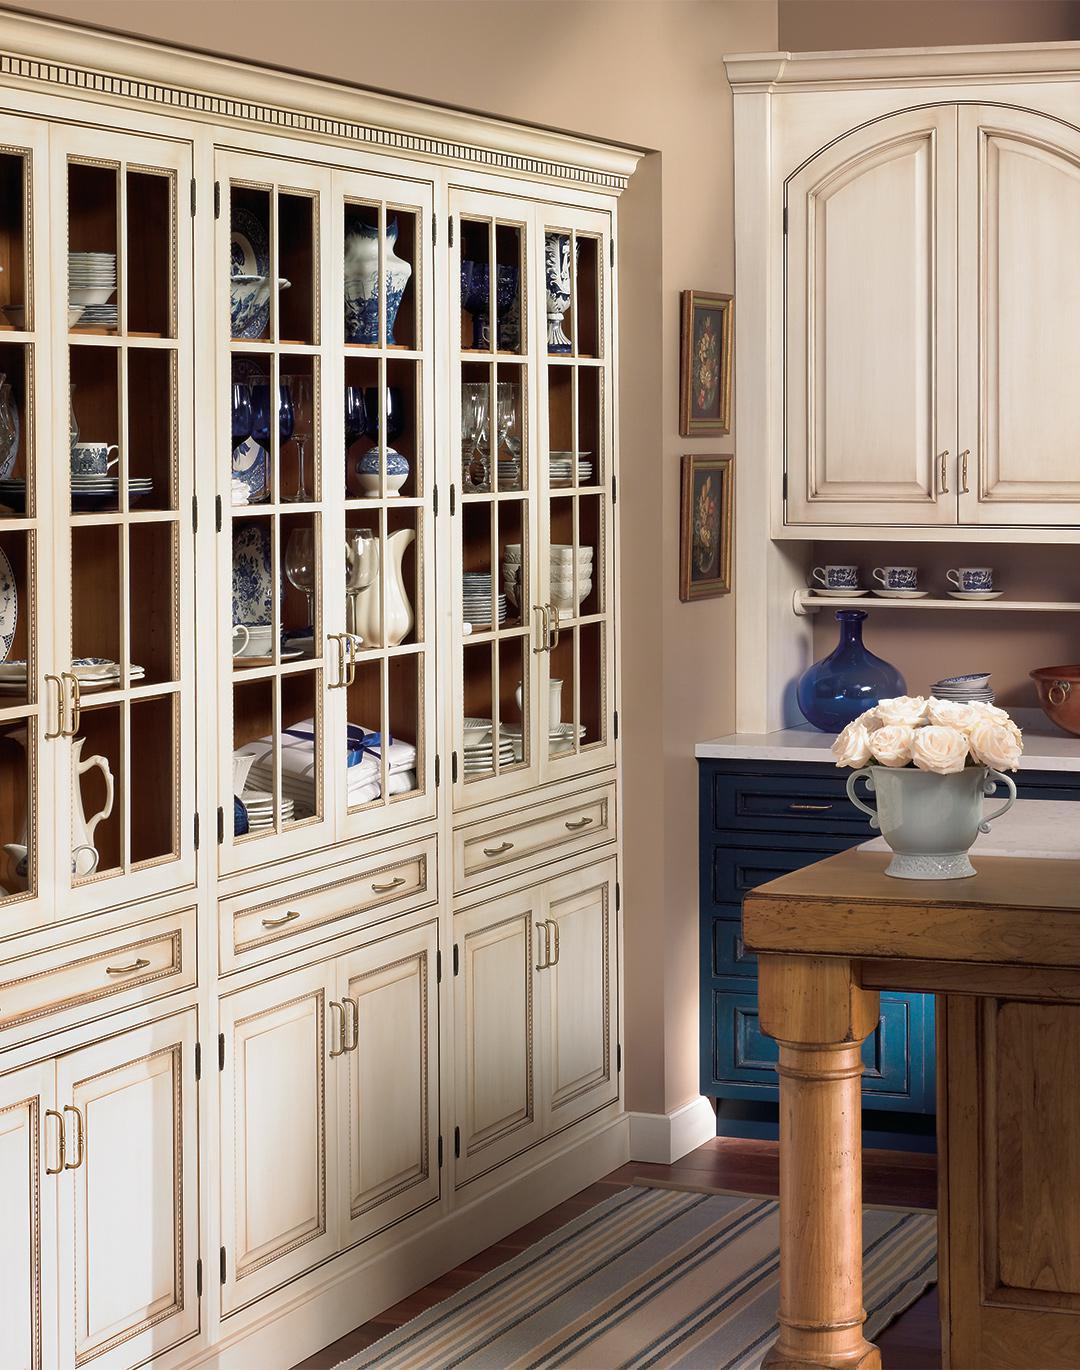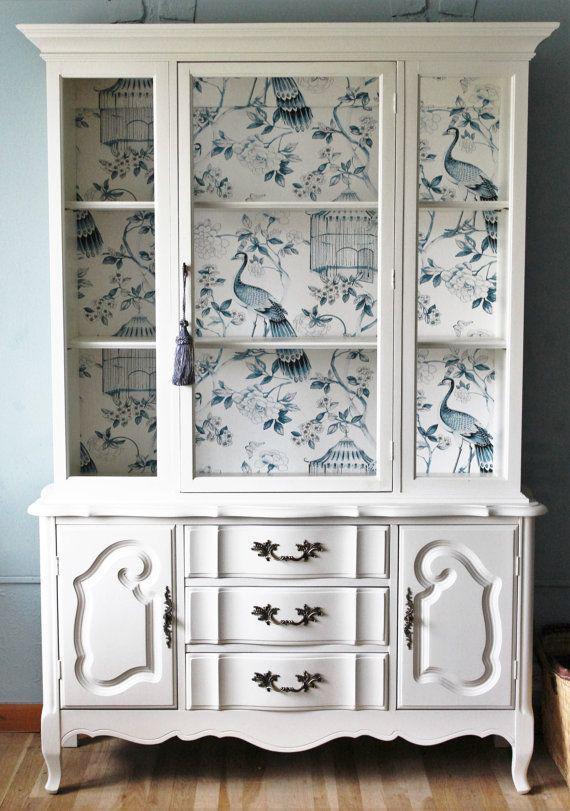The first image is the image on the left, the second image is the image on the right. For the images displayed, is the sentence "One image shows a bright white cabinet with a flat top." factually correct? Answer yes or no. Yes. The first image is the image on the left, the second image is the image on the right. For the images displayed, is the sentence "A large china cupboard unit in one image is built flush with the wall, with solid doors at the bottom and glass doors at the top." factually correct? Answer yes or no. Yes. 